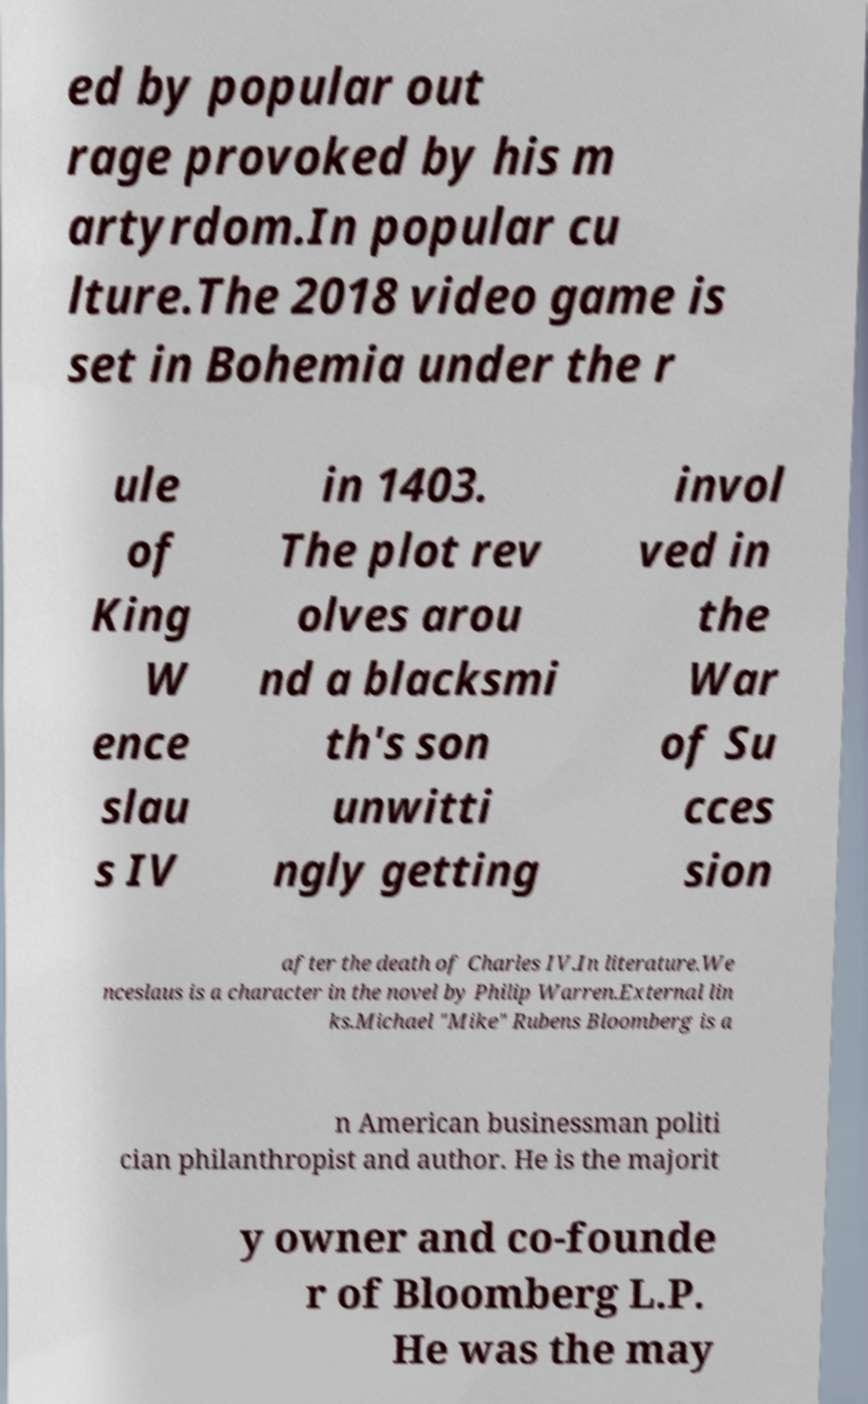There's text embedded in this image that I need extracted. Can you transcribe it verbatim? ed by popular out rage provoked by his m artyrdom.In popular cu lture.The 2018 video game is set in Bohemia under the r ule of King W ence slau s IV in 1403. The plot rev olves arou nd a blacksmi th's son unwitti ngly getting invol ved in the War of Su cces sion after the death of Charles IV.In literature.We nceslaus is a character in the novel by Philip Warren.External lin ks.Michael "Mike" Rubens Bloomberg is a n American businessman politi cian philanthropist and author. He is the majorit y owner and co-founde r of Bloomberg L.P. He was the may 